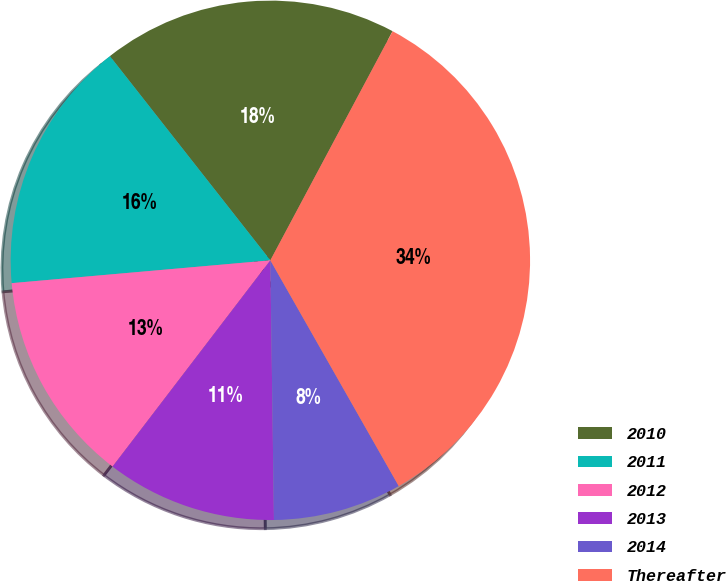Convert chart to OTSL. <chart><loc_0><loc_0><loc_500><loc_500><pie_chart><fcel>2010<fcel>2011<fcel>2012<fcel>2013<fcel>2014<fcel>Thereafter<nl><fcel>18.4%<fcel>15.8%<fcel>13.21%<fcel>10.61%<fcel>8.01%<fcel>33.97%<nl></chart> 